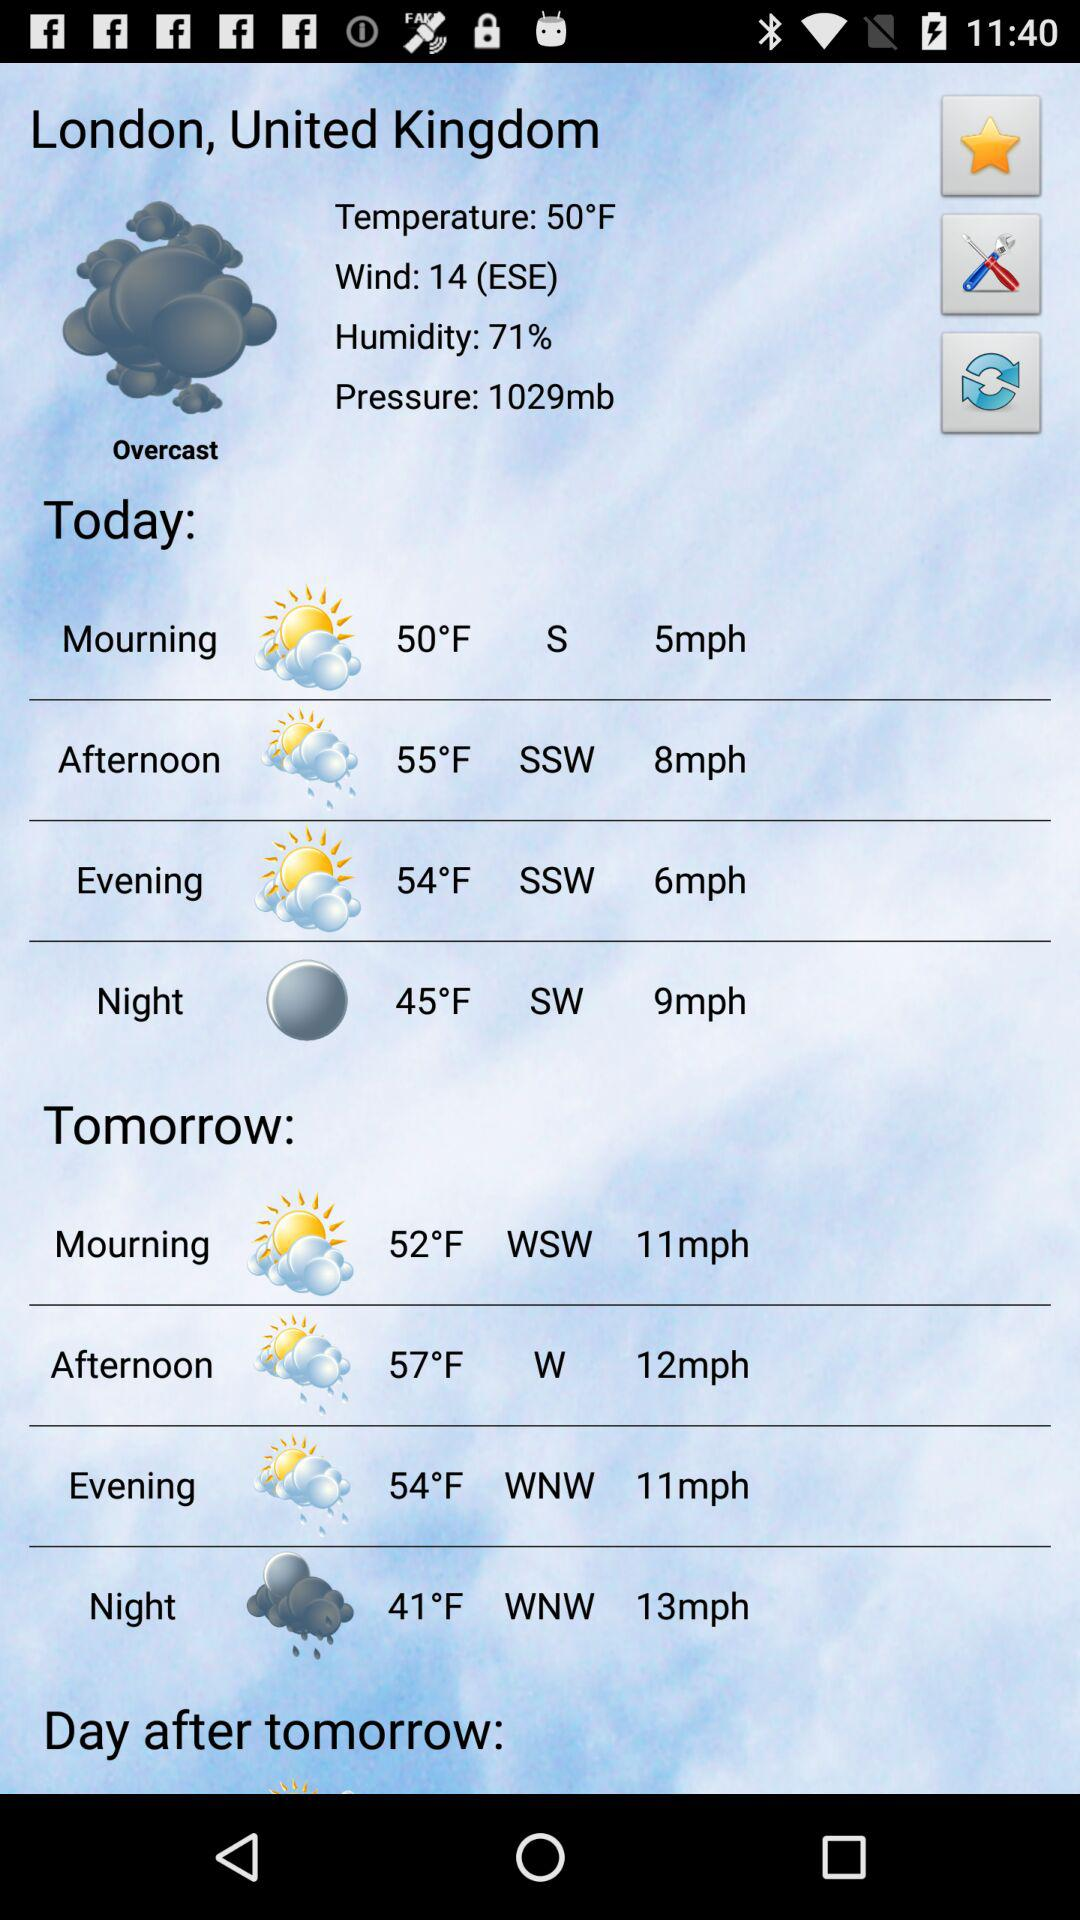What is the air pressure today in London, United Kingdom? Today's air pressure in London, United Kingdom, is 1029 mb. 